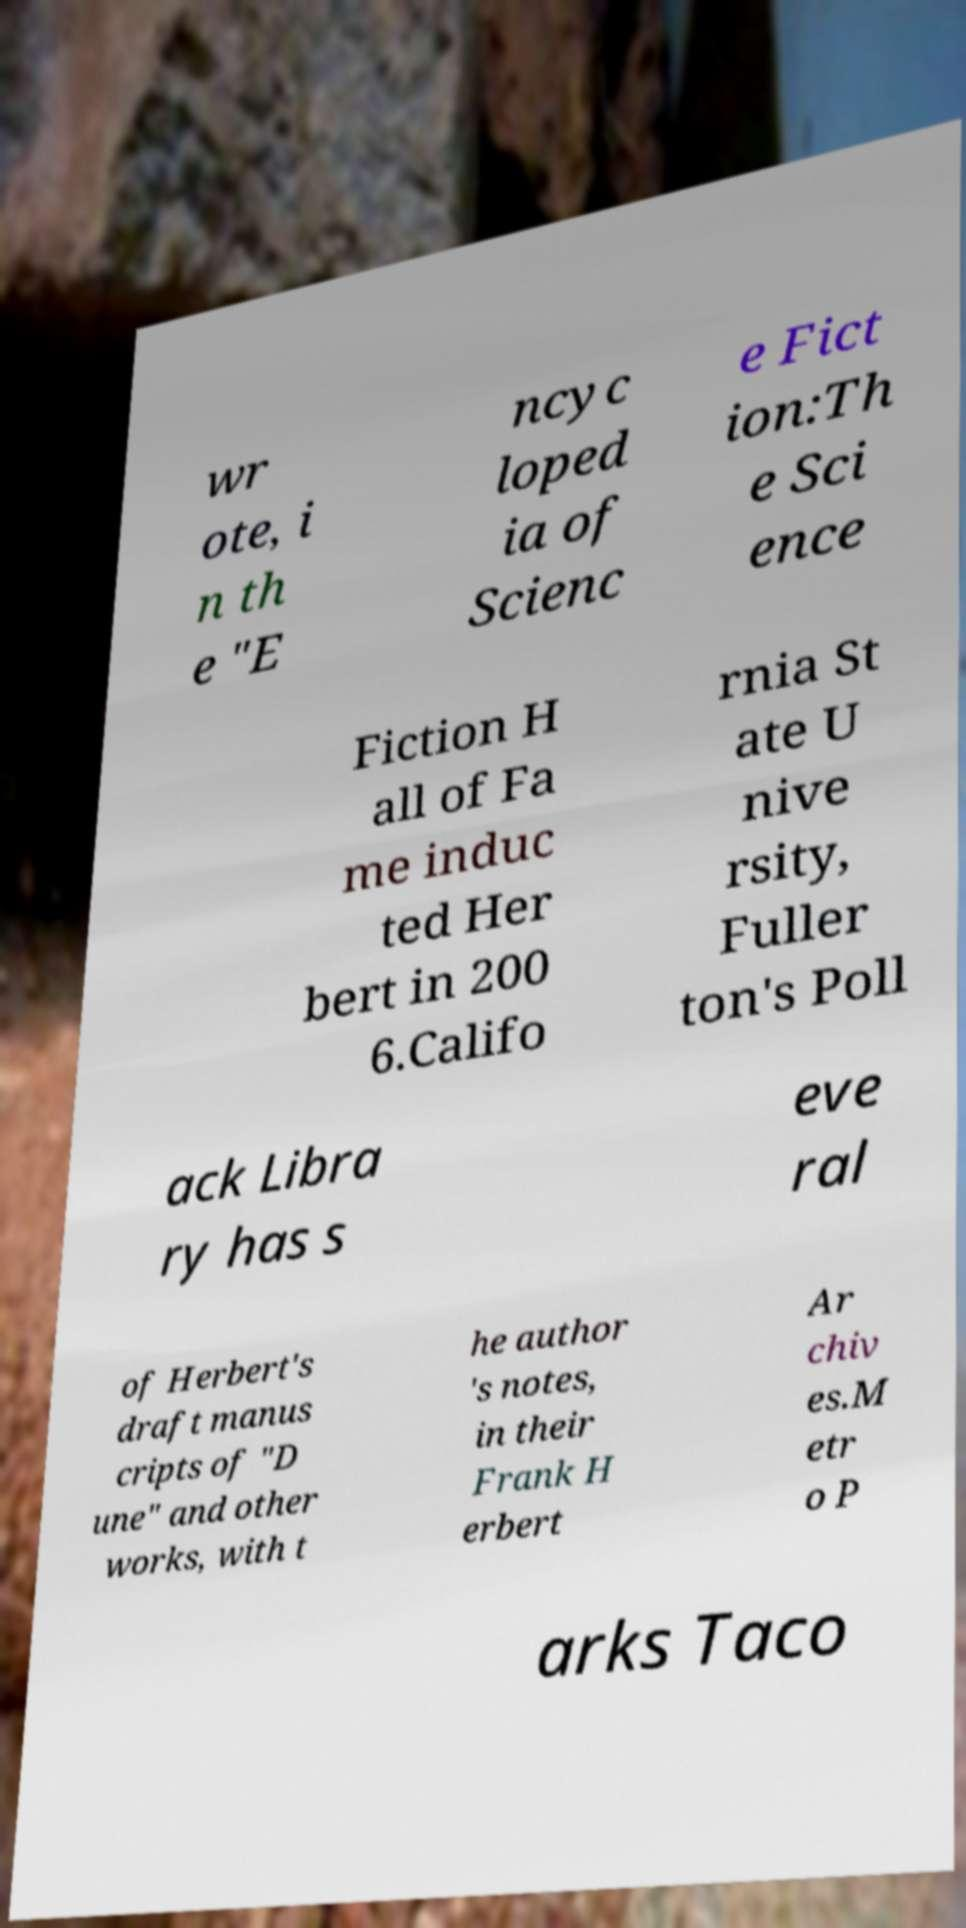Please read and relay the text visible in this image. What does it say? wr ote, i n th e "E ncyc loped ia of Scienc e Fict ion:Th e Sci ence Fiction H all of Fa me induc ted Her bert in 200 6.Califo rnia St ate U nive rsity, Fuller ton's Poll ack Libra ry has s eve ral of Herbert's draft manus cripts of "D une" and other works, with t he author 's notes, in their Frank H erbert Ar chiv es.M etr o P arks Taco 